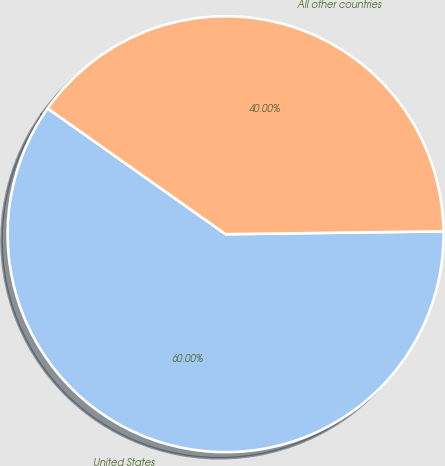Convert chart to OTSL. <chart><loc_0><loc_0><loc_500><loc_500><pie_chart><fcel>United States<fcel>All other countries<nl><fcel>60.0%<fcel>40.0%<nl></chart> 